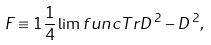<formula> <loc_0><loc_0><loc_500><loc_500>F \equiv 1 \frac { 1 } { 4 } \lim f u n c { T r } D ^ { \, 2 } - D ^ { \, 2 } ,</formula> 